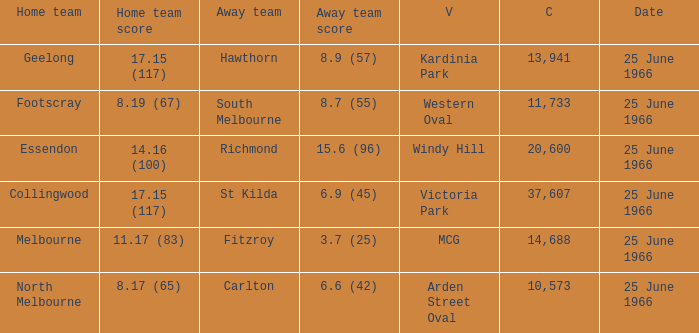Where did the away team score 8.7 (55)? Western Oval. 